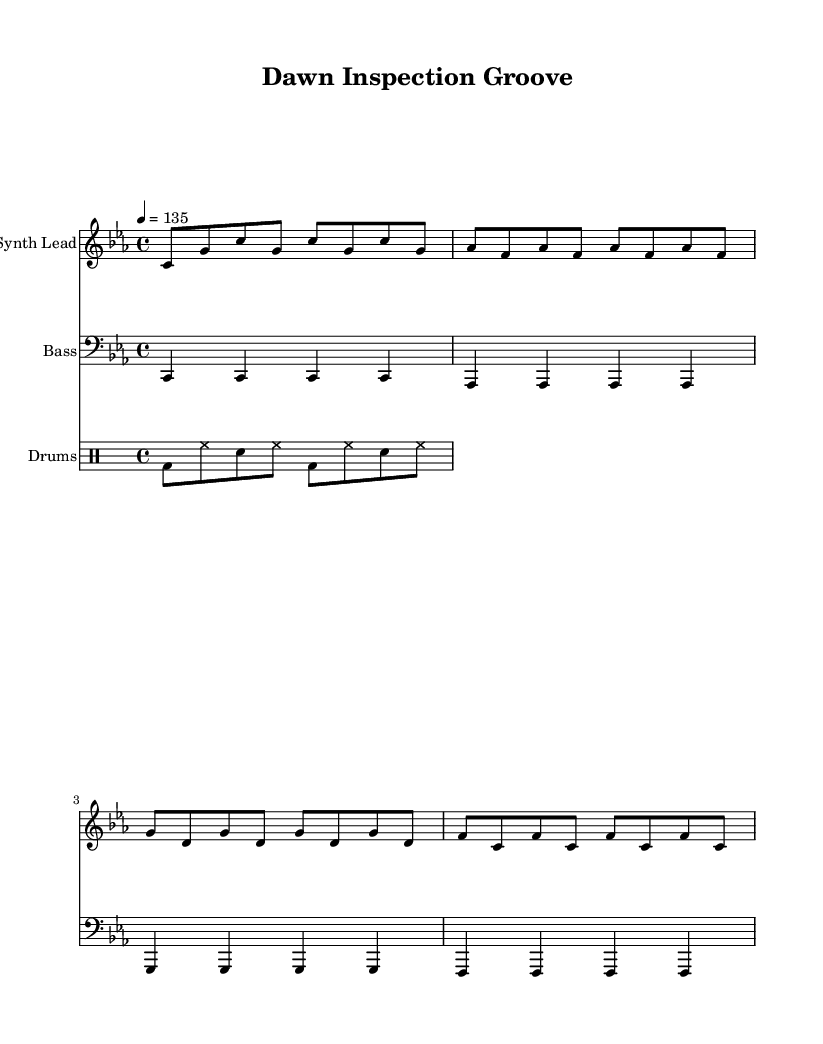What is the key signature of this music? The key is indicated as C minor, which has three flats: B♭, E♭, and A♭. This can be deduced from the global declaration in the code.
Answer: C minor What is the time signature of this music? The time signature is found in the global declaration and is written as 4/4, indicating four beats in a measure with a quarter note getting one beat.
Answer: 4/4 What is the tempo marking for this piece? The tempo is specified as 4 = 135 in the global section, meaning there are 135 beats per minute when counting a quarter note as one beat.
Answer: 135 What instrument plays the bass line? The bass line is written in the bass clef, which reveals that it is intended for a bass instrument. The declaration in the score specifies the "Bass" instrument name.
Answer: Bass How many measures are in the synth lead part? By counting the individual notes in the synth lead section, we can determine the number of measures. The synth lead part is subdivided into four main groups, or measures, of eight eighth notes.
Answer: 4 What type of rhythm pattern is used for the drums? The drum patterns are in a specific rhythm, indicated in the drummode. The pattern consists of bass drum, hi-hat, and snare combinations, which are typical for dance music's driving beats.
Answer: Dance rhythm Which section of the piece contains the highest pitch? Examining the synth lead line, we see that the highest pitch is in the notes C and G played in the first two measures. The synth lead generally has the upper melody range compared to bass instruments.
Answer: Synth Lead 